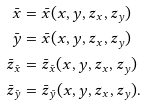<formula> <loc_0><loc_0><loc_500><loc_500>\bar { x } & = \bar { x } ( x , y , z _ { x } , z _ { y } ) \\ \bar { y } & = \bar { x } ( x , y , z _ { x } , z _ { y } ) \\ \bar { z } _ { \bar { x } } & = \bar { z } _ { \bar { x } } ( x , y , z _ { x } , z _ { y } ) \\ \bar { z } _ { \bar { y } } & = \bar { z } _ { \bar { y } } ( x , y , z _ { x } , z _ { y } ) .</formula> 